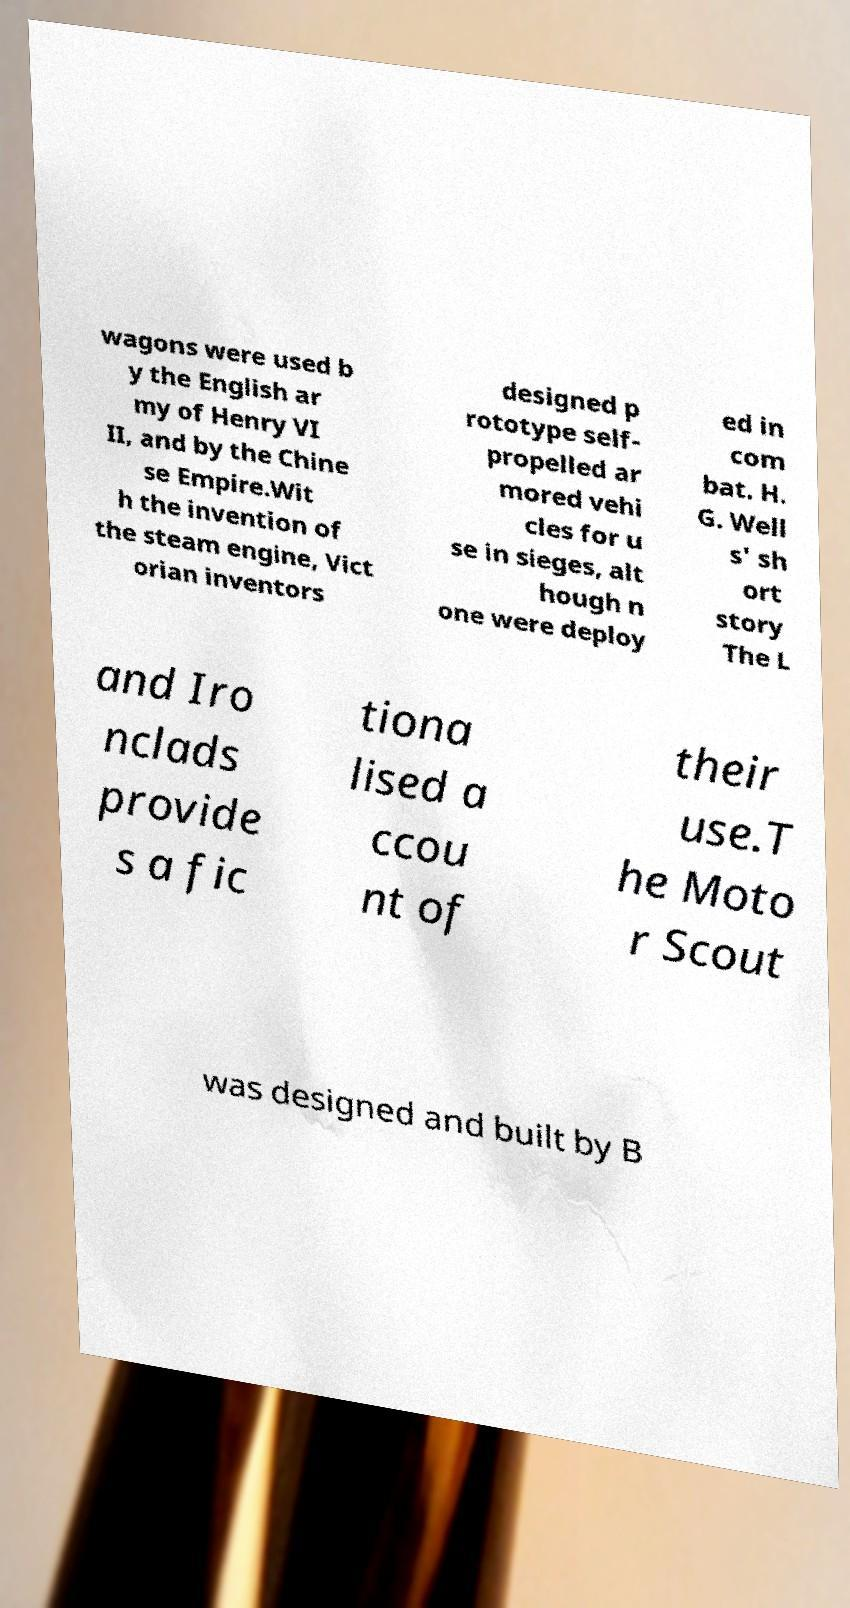Please identify and transcribe the text found in this image. wagons were used b y the English ar my of Henry VI II, and by the Chine se Empire.Wit h the invention of the steam engine, Vict orian inventors designed p rototype self- propelled ar mored vehi cles for u se in sieges, alt hough n one were deploy ed in com bat. H. G. Well s' sh ort story The L and Iro nclads provide s a fic tiona lised a ccou nt of their use.T he Moto r Scout was designed and built by B 